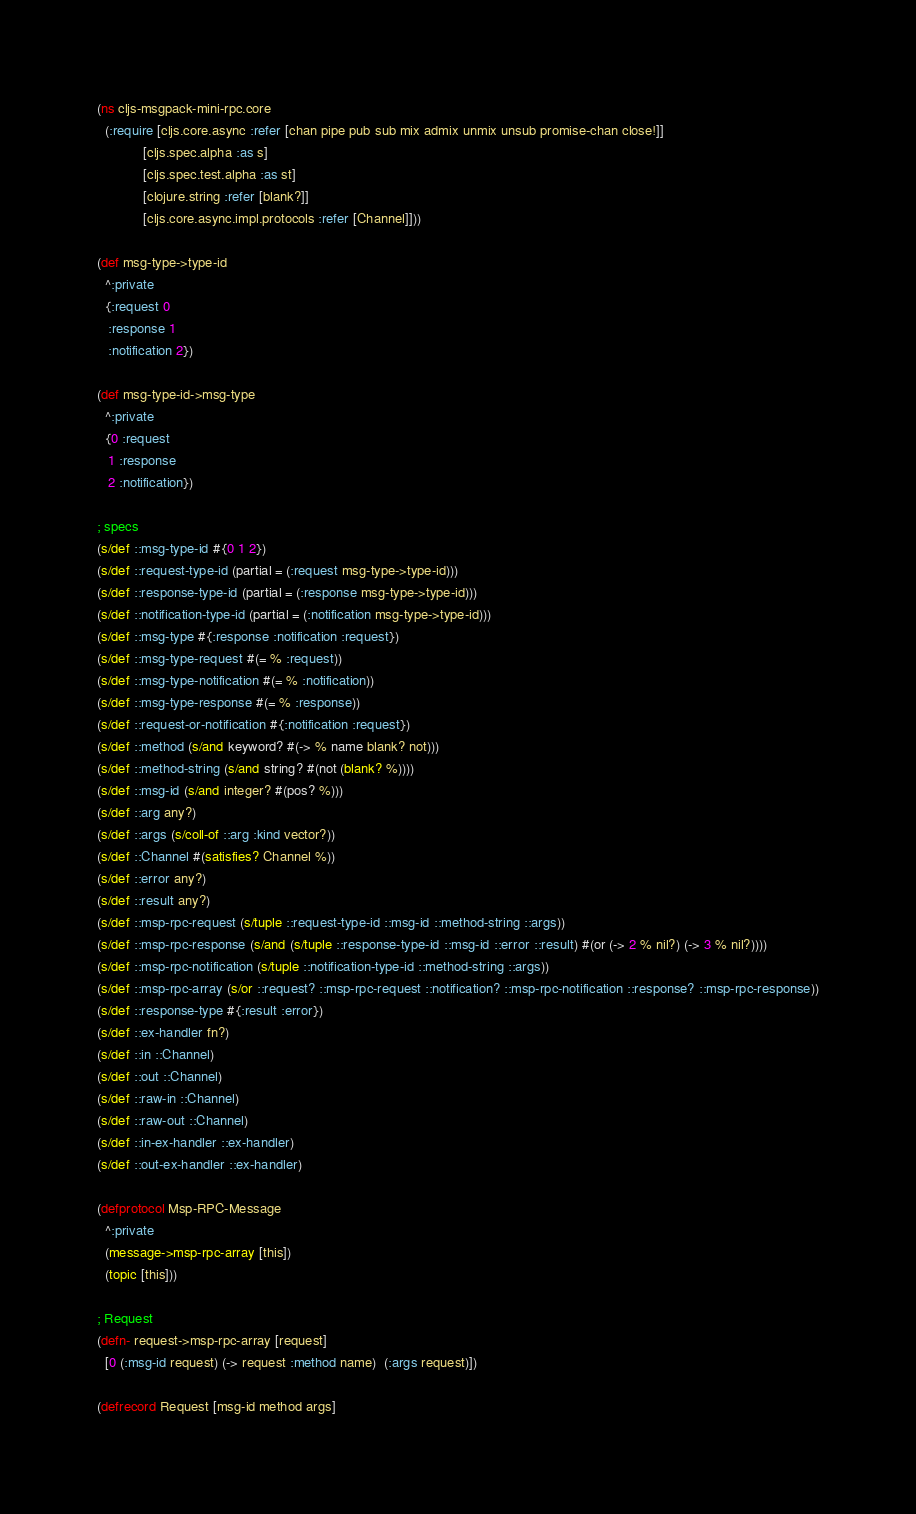<code> <loc_0><loc_0><loc_500><loc_500><_Clojure_>(ns cljs-msgpack-mini-rpc.core
  (:require [cljs.core.async :refer [chan pipe pub sub mix admix unmix unsub promise-chan close!]]
            [cljs.spec.alpha :as s]
            [cljs.spec.test.alpha :as st]
            [clojure.string :refer [blank?]]
            [cljs.core.async.impl.protocols :refer [Channel]]))

(def msg-type->type-id
  ^:private
  {:request 0
   :response 1
   :notification 2})

(def msg-type-id->msg-type
  ^:private
  {0 :request
   1 :response
   2 :notification})

; specs
(s/def ::msg-type-id #{0 1 2})
(s/def ::request-type-id (partial = (:request msg-type->type-id)))
(s/def ::response-type-id (partial = (:response msg-type->type-id)))
(s/def ::notification-type-id (partial = (:notification msg-type->type-id)))
(s/def ::msg-type #{:response :notification :request})
(s/def ::msg-type-request #(= % :request))
(s/def ::msg-type-notification #(= % :notification))
(s/def ::msg-type-response #(= % :response))
(s/def ::request-or-notification #{:notification :request})
(s/def ::method (s/and keyword? #(-> % name blank? not)))
(s/def ::method-string (s/and string? #(not (blank? %))))
(s/def ::msg-id (s/and integer? #(pos? %)))
(s/def ::arg any?)
(s/def ::args (s/coll-of ::arg :kind vector?))
(s/def ::Channel #(satisfies? Channel %))
(s/def ::error any?)
(s/def ::result any?)
(s/def ::msp-rpc-request (s/tuple ::request-type-id ::msg-id ::method-string ::args))
(s/def ::msp-rpc-response (s/and (s/tuple ::response-type-id ::msg-id ::error ::result) #(or (-> 2 % nil?) (-> 3 % nil?))))
(s/def ::msp-rpc-notification (s/tuple ::notification-type-id ::method-string ::args))
(s/def ::msp-rpc-array (s/or ::request? ::msp-rpc-request ::notification? ::msp-rpc-notification ::response? ::msp-rpc-response))
(s/def ::response-type #{:result :error})
(s/def ::ex-handler fn?)
(s/def ::in ::Channel)
(s/def ::out ::Channel)
(s/def ::raw-in ::Channel)
(s/def ::raw-out ::Channel)
(s/def ::in-ex-handler ::ex-handler)
(s/def ::out-ex-handler ::ex-handler)

(defprotocol Msp-RPC-Message
  ^:private
  (message->msp-rpc-array [this])
  (topic [this]))

; Request
(defn- request->msp-rpc-array [request]
  [0 (:msg-id request) (-> request :method name)  (:args request)])

(defrecord Request [msg-id method args]</code> 